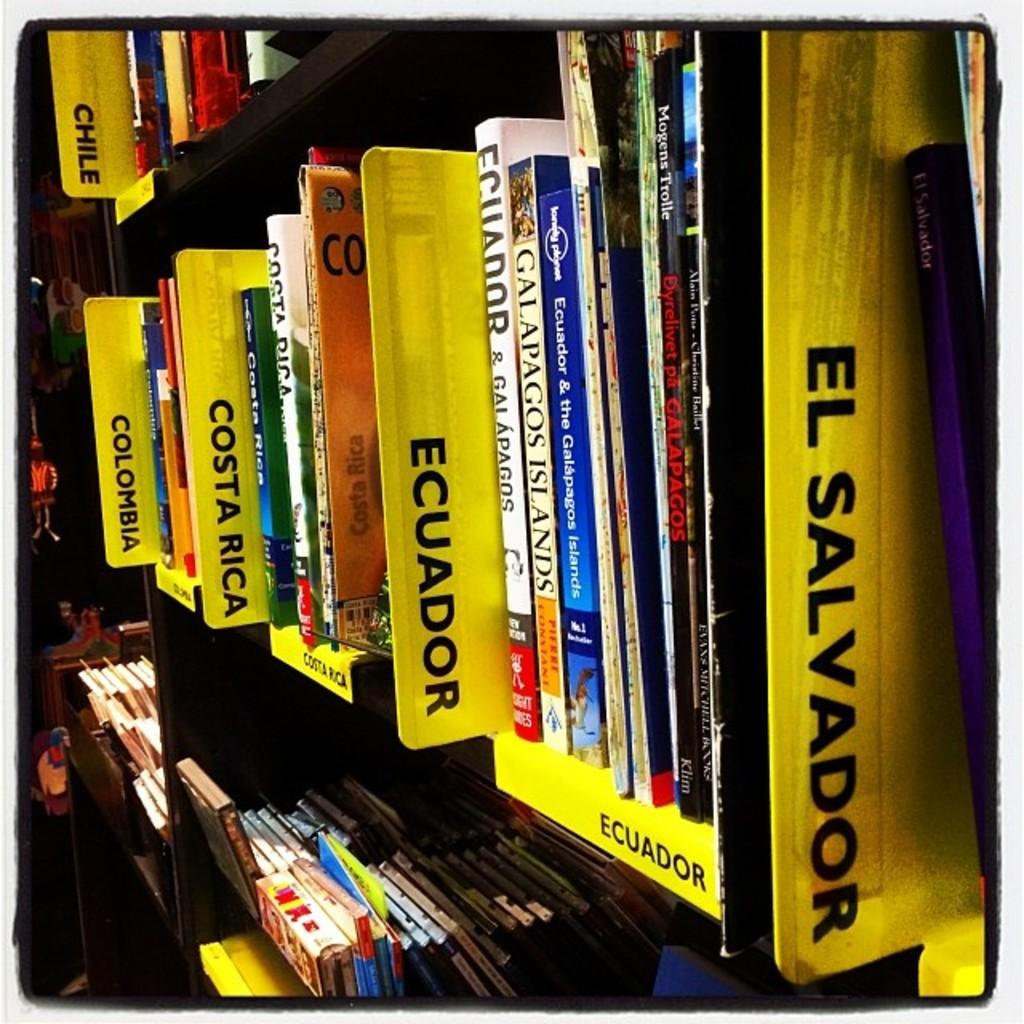<image>
Render a clear and concise summary of the photo. a shelf of books with a divider that says ecuador on it 